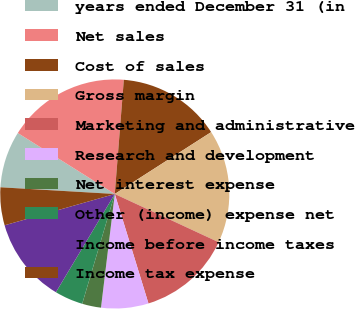Convert chart. <chart><loc_0><loc_0><loc_500><loc_500><pie_chart><fcel>years ended December 31 (in<fcel>Net sales<fcel>Cost of sales<fcel>Gross margin<fcel>Marketing and administrative<fcel>Research and development<fcel>Net interest expense<fcel>Other (income) expense net<fcel>Income before income taxes<fcel>Income tax expense<nl><fcel>8.0%<fcel>17.33%<fcel>14.66%<fcel>16.0%<fcel>13.33%<fcel>6.67%<fcel>2.67%<fcel>4.0%<fcel>12.0%<fcel>5.34%<nl></chart> 